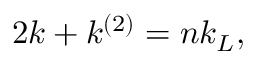<formula> <loc_0><loc_0><loc_500><loc_500>2 k + k ^ { \left ( 2 \right ) } = n k _ { L } ,</formula> 